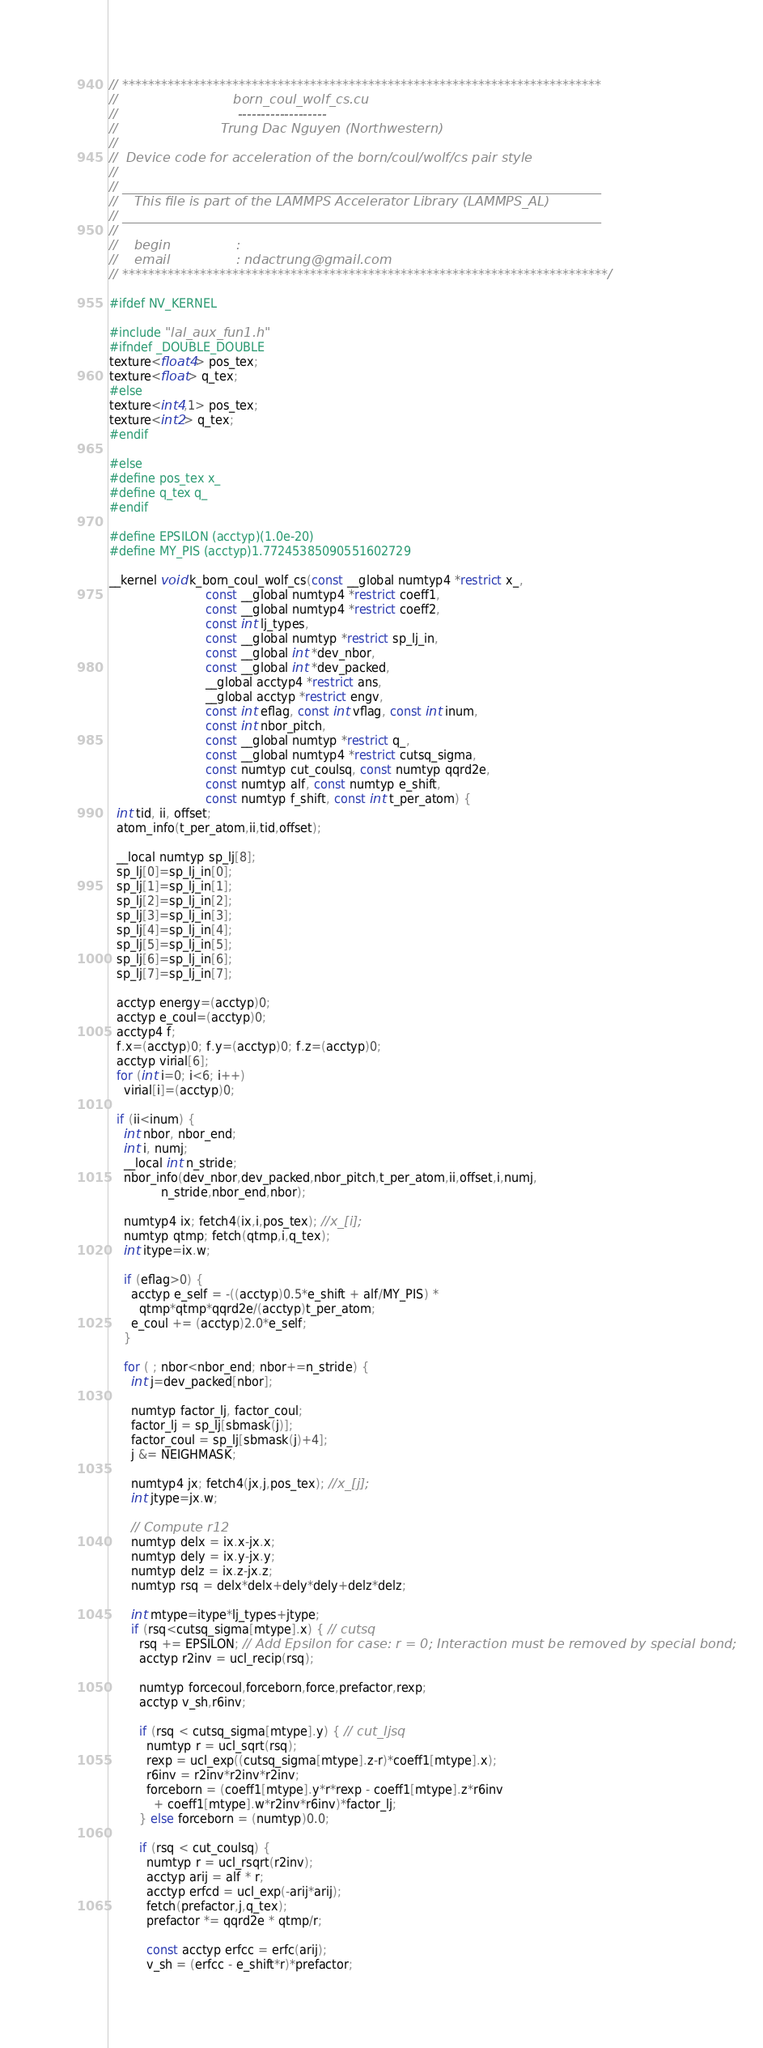<code> <loc_0><loc_0><loc_500><loc_500><_Cuda_>// **************************************************************************
//                            born_coul_wolf_cs.cu
//                             -------------------
//                         Trung Dac Nguyen (Northwestern)
//
//  Device code for acceleration of the born/coul/wolf/cs pair style
//
// __________________________________________________________________________
//    This file is part of the LAMMPS Accelerator Library (LAMMPS_AL)
// __________________________________________________________________________
//
//    begin                :
//    email                : ndactrung@gmail.com
// ***************************************************************************/

#ifdef NV_KERNEL

#include "lal_aux_fun1.h"
#ifndef _DOUBLE_DOUBLE
texture<float4> pos_tex;
texture<float> q_tex;
#else
texture<int4,1> pos_tex;
texture<int2> q_tex;
#endif

#else
#define pos_tex x_
#define q_tex q_
#endif

#define EPSILON (acctyp)(1.0e-20)
#define MY_PIS (acctyp)1.77245385090551602729

__kernel void k_born_coul_wolf_cs(const __global numtyp4 *restrict x_,
                          const __global numtyp4 *restrict coeff1,
                          const __global numtyp4 *restrict coeff2,
                          const int lj_types,
                          const __global numtyp *restrict sp_lj_in,
                          const __global int *dev_nbor,
                          const __global int *dev_packed,
                          __global acctyp4 *restrict ans,
                          __global acctyp *restrict engv,
                          const int eflag, const int vflag, const int inum,
                          const int nbor_pitch,
                          const __global numtyp *restrict q_,
                          const __global numtyp4 *restrict cutsq_sigma,
                          const numtyp cut_coulsq, const numtyp qqrd2e,
                          const numtyp alf, const numtyp e_shift,
                          const numtyp f_shift, const int t_per_atom) {
  int tid, ii, offset;
  atom_info(t_per_atom,ii,tid,offset);

  __local numtyp sp_lj[8];
  sp_lj[0]=sp_lj_in[0];
  sp_lj[1]=sp_lj_in[1];
  sp_lj[2]=sp_lj_in[2];
  sp_lj[3]=sp_lj_in[3];
  sp_lj[4]=sp_lj_in[4];
  sp_lj[5]=sp_lj_in[5];
  sp_lj[6]=sp_lj_in[6];
  sp_lj[7]=sp_lj_in[7];

  acctyp energy=(acctyp)0;
  acctyp e_coul=(acctyp)0;
  acctyp4 f;
  f.x=(acctyp)0; f.y=(acctyp)0; f.z=(acctyp)0;
  acctyp virial[6];
  for (int i=0; i<6; i++)
    virial[i]=(acctyp)0;

  if (ii<inum) {
    int nbor, nbor_end;
    int i, numj;
    __local int n_stride;
    nbor_info(dev_nbor,dev_packed,nbor_pitch,t_per_atom,ii,offset,i,numj,
              n_stride,nbor_end,nbor);

    numtyp4 ix; fetch4(ix,i,pos_tex); //x_[i];
    numtyp qtmp; fetch(qtmp,i,q_tex);
    int itype=ix.w;

    if (eflag>0) {
      acctyp e_self = -((acctyp)0.5*e_shift + alf/MY_PIS) *
        qtmp*qtmp*qqrd2e/(acctyp)t_per_atom;
      e_coul += (acctyp)2.0*e_self;
    }

    for ( ; nbor<nbor_end; nbor+=n_stride) {
      int j=dev_packed[nbor];

      numtyp factor_lj, factor_coul;
      factor_lj = sp_lj[sbmask(j)];
      factor_coul = sp_lj[sbmask(j)+4];
      j &= NEIGHMASK;

      numtyp4 jx; fetch4(jx,j,pos_tex); //x_[j];
      int jtype=jx.w;

      // Compute r12
      numtyp delx = ix.x-jx.x;
      numtyp dely = ix.y-jx.y;
      numtyp delz = ix.z-jx.z;
      numtyp rsq = delx*delx+dely*dely+delz*delz;

      int mtype=itype*lj_types+jtype;
      if (rsq<cutsq_sigma[mtype].x) { // cutsq
        rsq += EPSILON; // Add Epsilon for case: r = 0; Interaction must be removed by special bond;
        acctyp r2inv = ucl_recip(rsq);

        numtyp forcecoul,forceborn,force,prefactor,rexp;
        acctyp v_sh,r6inv;

        if (rsq < cutsq_sigma[mtype].y) { // cut_ljsq
          numtyp r = ucl_sqrt(rsq);
          rexp = ucl_exp((cutsq_sigma[mtype].z-r)*coeff1[mtype].x);
          r6inv = r2inv*r2inv*r2inv;
          forceborn = (coeff1[mtype].y*r*rexp - coeff1[mtype].z*r6inv
            + coeff1[mtype].w*r2inv*r6inv)*factor_lj;
        } else forceborn = (numtyp)0.0;

        if (rsq < cut_coulsq) {
          numtyp r = ucl_rsqrt(r2inv);
          acctyp arij = alf * r;
          acctyp erfcd = ucl_exp(-arij*arij);
          fetch(prefactor,j,q_tex);
          prefactor *= qqrd2e * qtmp/r;

          const acctyp erfcc = erfc(arij);
          v_sh = (erfcc - e_shift*r)*prefactor;</code> 